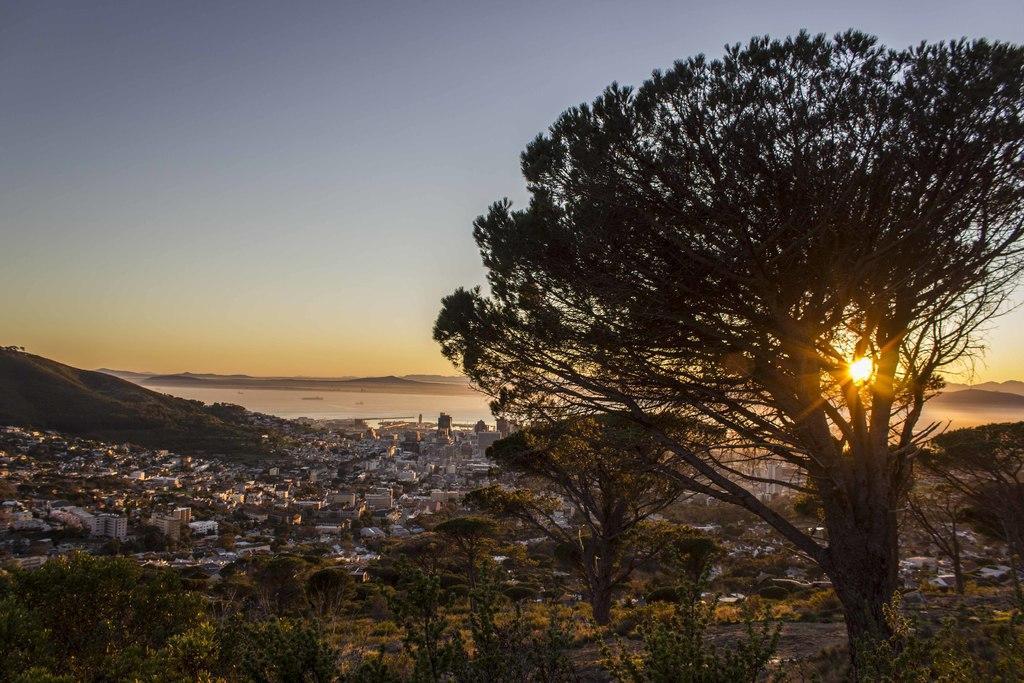Please provide a concise description of this image. In this picture I can see number of trees in front and in the middle of this picture I can see number of buildings. In the background I can see the sky and on the right side of this picture I can see the sun. 